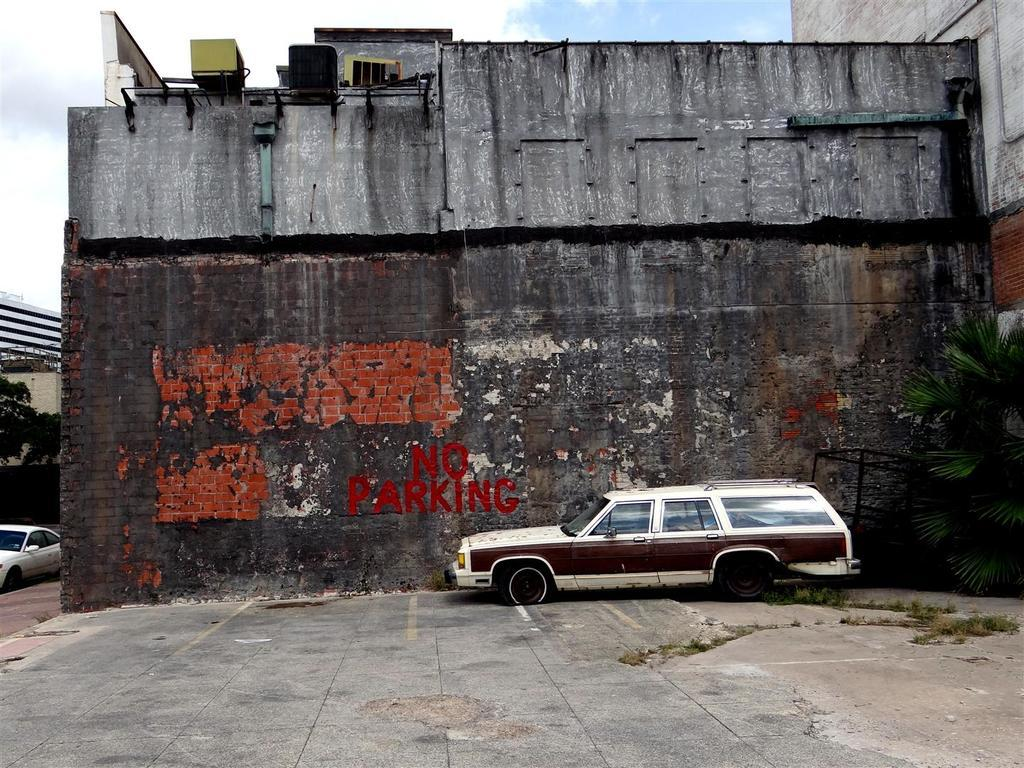What is on the wall in the image? There is a stand on the wall in the image. What objects can be seen on the ground in the image? Vehicles are present on the ground in the image. What type of structure is visible in the image? There is a building in the image. What type of plant is in the image? There is a tree in the image. What part of the natural environment is visible in the image? The sky is visible in the image. Where is the oil stored in the image? There is no oil or storage container for oil present in the image. What type of agreement is being made in the image? There is no indication of any agreement being made in the image. 